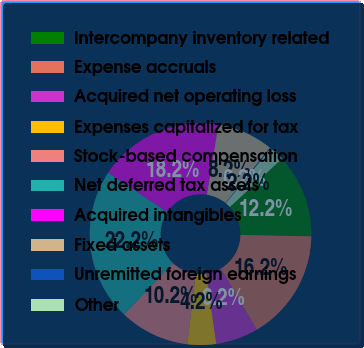<chart> <loc_0><loc_0><loc_500><loc_500><pie_chart><fcel>Intercompany inventory related<fcel>Expense accruals<fcel>Acquired net operating loss<fcel>Expenses capitalized for tax<fcel>Stock-based compensation<fcel>Net deferred tax assets<fcel>Acquired intangibles<fcel>Fixed assets<fcel>Unremitted foreign earnings<fcel>Other<nl><fcel>12.21%<fcel>16.22%<fcel>6.19%<fcel>4.18%<fcel>10.2%<fcel>22.24%<fcel>18.23%<fcel>8.19%<fcel>0.16%<fcel>2.17%<nl></chart> 